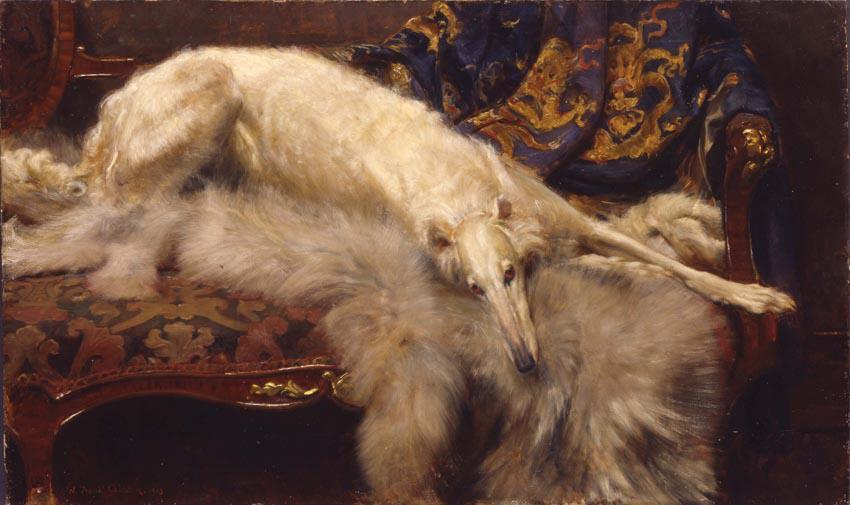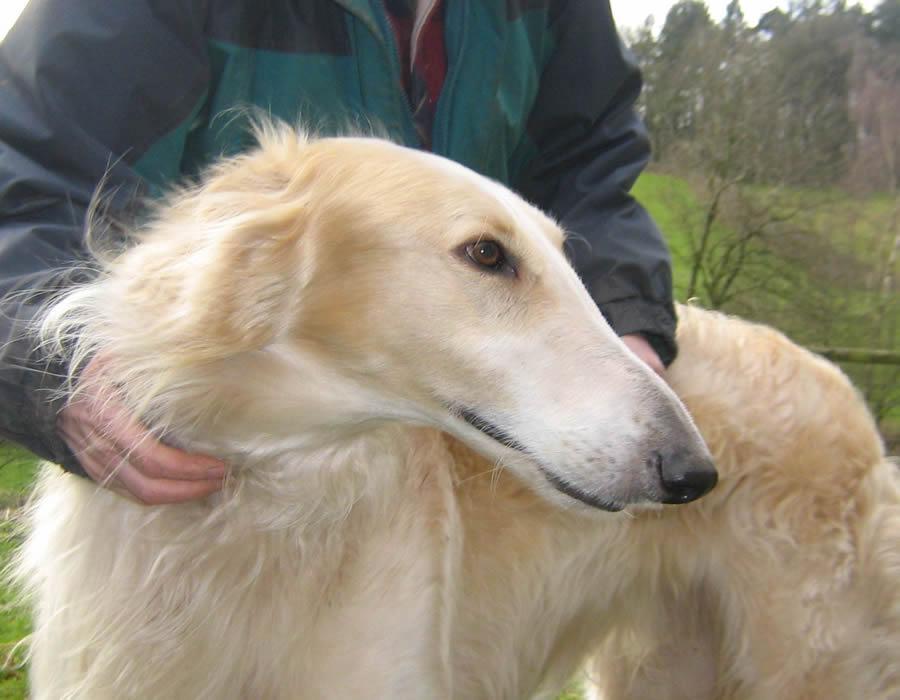The first image is the image on the left, the second image is the image on the right. For the images shown, is this caption "The dog in one of the images is lying down on a piece of furniture." true? Answer yes or no. Yes. 